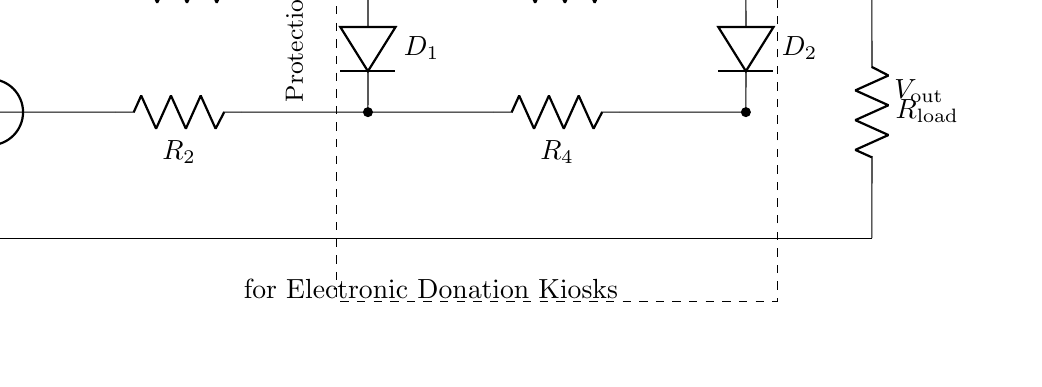What is the purpose of D1 and D2 in the circuit? D1 and D2 function as protection devices that allow current to flow in one direction, preventing damage from excess voltage by clamping the output.
Answer: Protection devices What components are used in the protection stage? The protection stage is composed of two diodes (D1, D2) and resistors (R1, R2, R3, R4) that work together to safeguard the circuit.
Answer: Two diodes and four resistors Which resistor in the circuit serves as the load? R_load is the component that represents the load being powered by the circuit.
Answer: R_load How many resistors are in the circuit? There are four resistors (R1, R2, R3, R4) in the circuit that are part of the overvoltage protection design.
Answer: Four What is the effect of overvoltage on the donation kiosk? Overvoltage can potentially damage the electronic components within the kiosk, which is why the protection circuit is essential.
Answer: Damage to electronic components What is the connection type used for D1 and D2? D1 and D2 are connected in parallel with the resistors in the protection section, allowing them to divert excessive voltage.
Answer: Parallel connection What does V_out represent in the circuit? V_out represents the output voltage that is delivered to the load after overvoltage protection has been applied.
Answer: Output voltage 